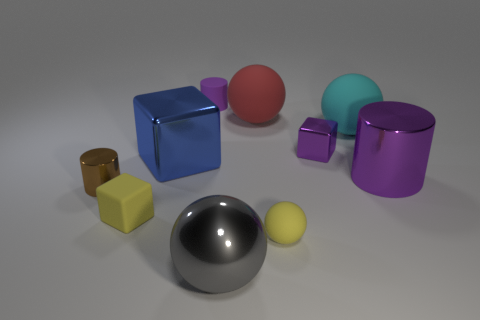Subtract all green spheres. Subtract all green cubes. How many spheres are left? 4 Subtract all blocks. How many objects are left? 7 Add 8 red spheres. How many red spheres exist? 9 Subtract 0 cyan cylinders. How many objects are left? 10 Subtract all tiny yellow rubber cubes. Subtract all tiny matte cubes. How many objects are left? 8 Add 4 cylinders. How many cylinders are left? 7 